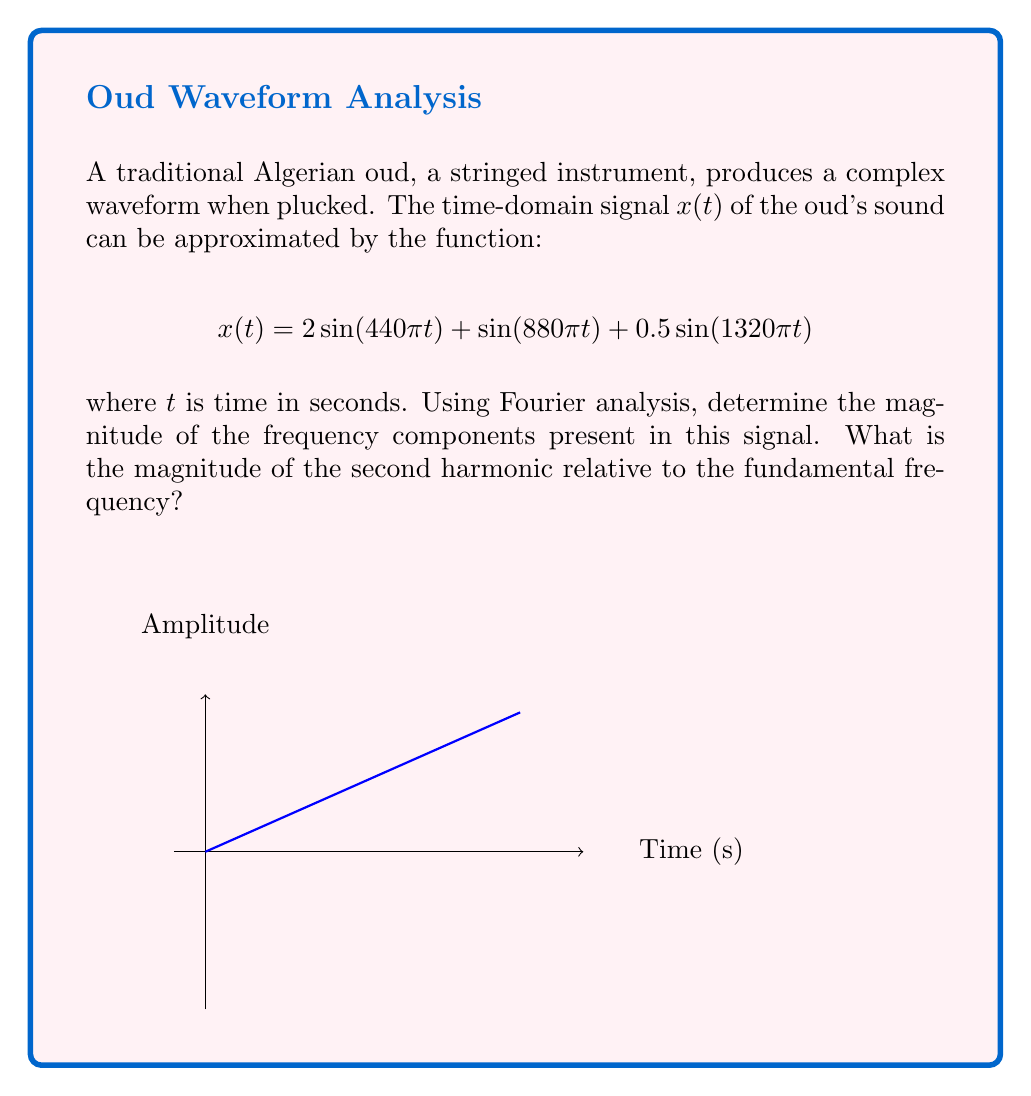Give your solution to this math problem. To determine the frequency response using Fourier analysis, we need to identify the frequency components and their magnitudes in the given signal.

1) The given signal $x(t)$ is already expressed as a sum of sinusoids, which is the form of a Fourier series. Each sinusoid represents a frequency component.

2) Let's break down the components:
   
   a) $2\sin(440\pi t)$: Fundamental frequency
      Frequency = $440\pi/(2\pi) = 220$ Hz
      Magnitude = 2
   
   b) $\sin(880\pi t)$: Second harmonic
      Frequency = $880\pi/(2\pi) = 440$ Hz
      Magnitude = 1
   
   c) $0.5\sin(1320\pi t)$: Third harmonic
      Frequency = $1320\pi/(2\pi) = 660$ Hz
      Magnitude = 0.5

3) The magnitude of the second harmonic relative to the fundamental is:

   $$\frac{\text{Magnitude of second harmonic}}{\text{Magnitude of fundamental}} = \frac{1}{2} = 0.5$$

4) This means the second harmonic has half the magnitude of the fundamental frequency.
Answer: 0.5 